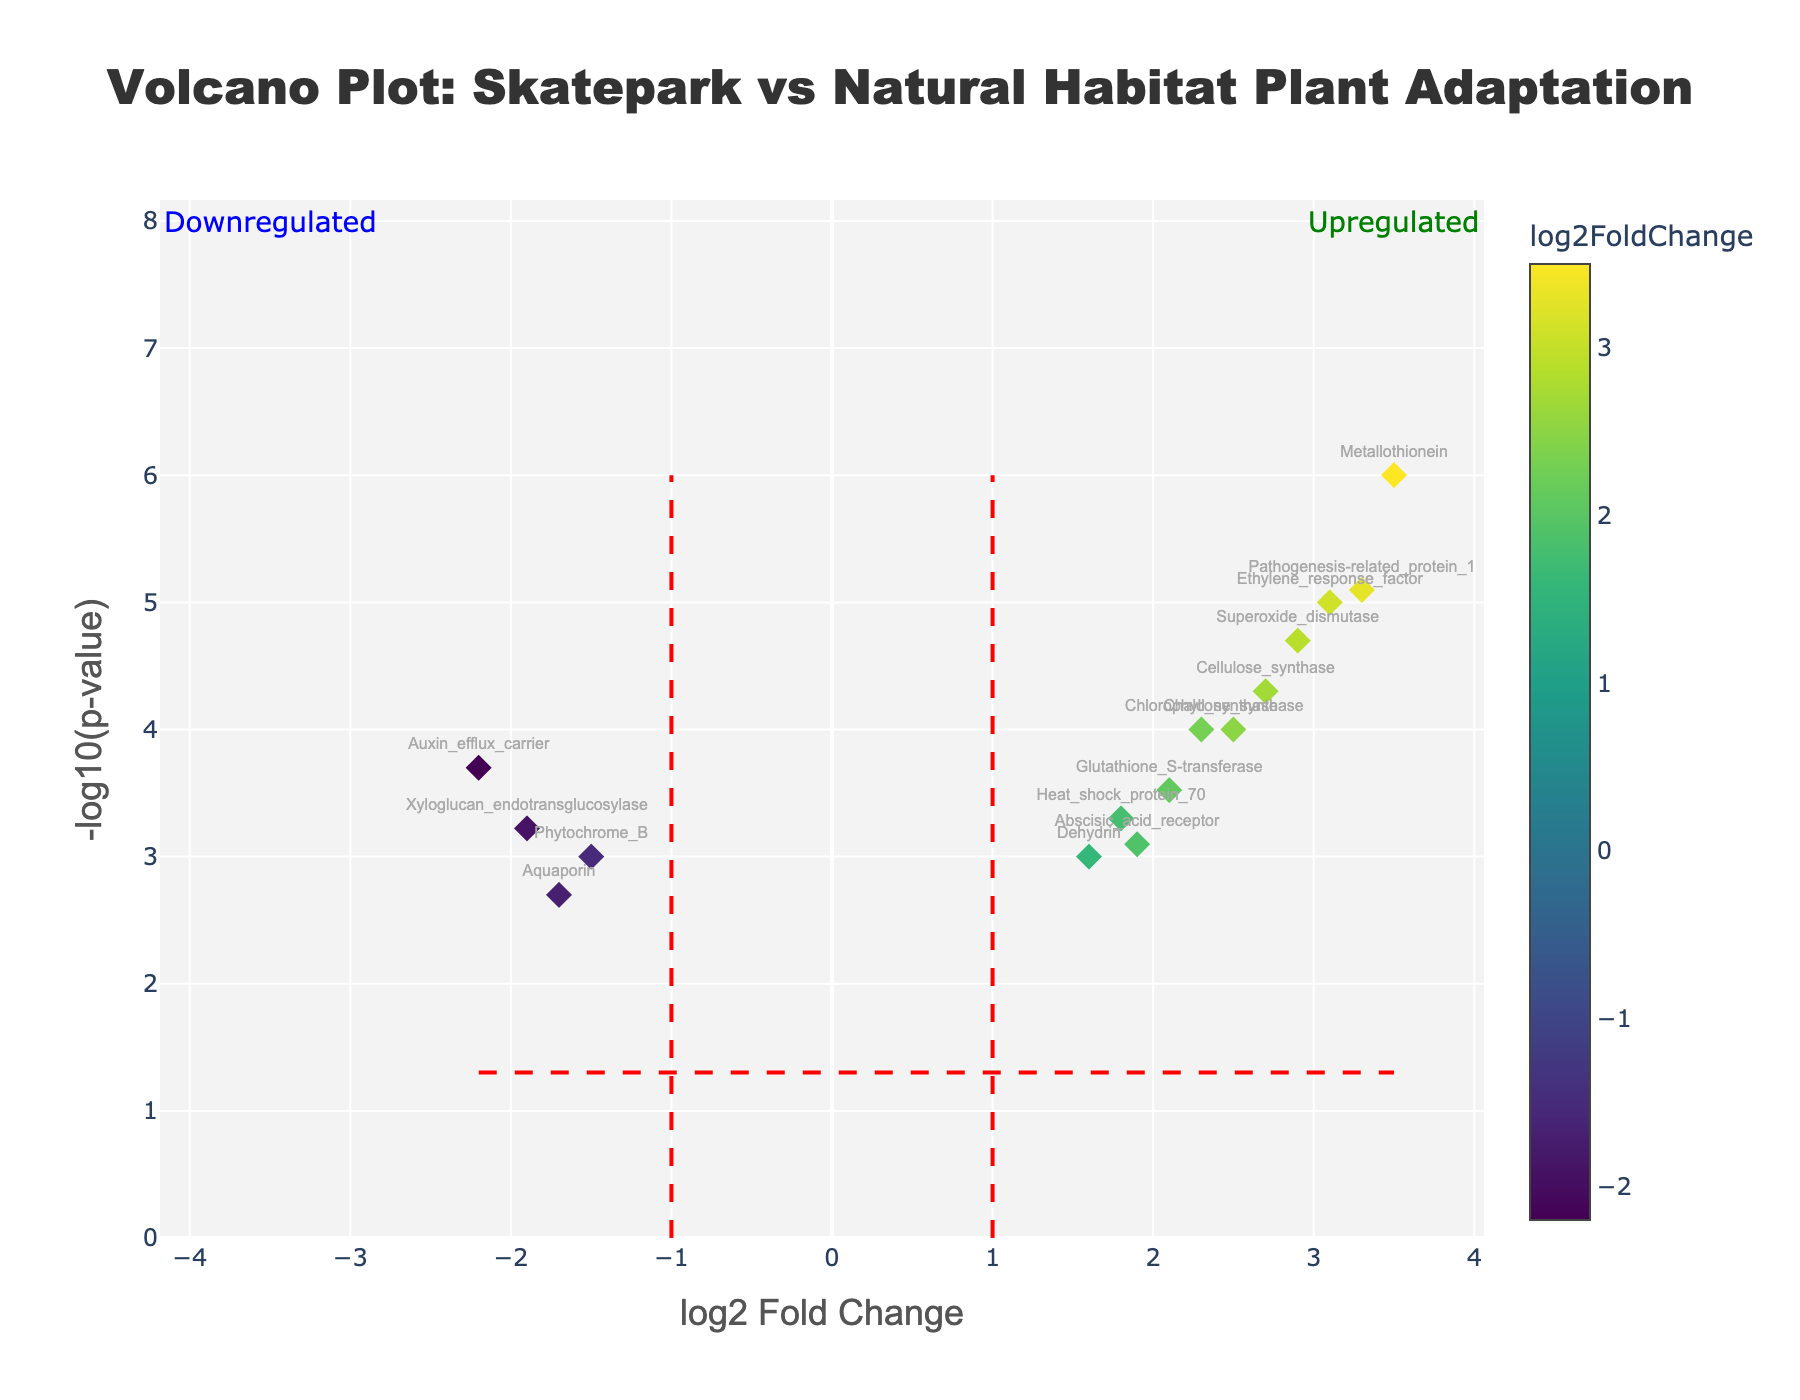What is the title of the figure? The title is usually located at the top of the figure. In this case, it is centered at the top and reads "Volcano Plot: Skatepark vs Natural Habitat Plant Adaptation".
Answer: "Volcano Plot: Skatepark vs Natural Habitat Plant Adaptation" What do the x-axis and y-axis represent? The x-axis title is “log2 Fold Change” and it indicates the fold change in gene expression levels, while the y-axis title is “-log10(p-value)” and it indicates the significance of the gene expression changes.
Answer: log2 Fold Change (x-axis) and -log10(p-value) (y-axis) Which gene has the highest -log10(p-value)? To find the gene with the highest -log10(p-value), look for the point that is highest on the y-axis. The gene "Metallothionein" appears at the highest point.
Answer: Metallothionein Which gene is most significantly downregulated in plants growing in skate parks? Downregulated genes have negative log2FoldChange values. Among them, identify the one with the highest -log10(p-value). "Auxin_efflux_carrier" has the most significant negative log2FoldChange and high -log10(p-value).
Answer: Auxin_efflux_carrier How many genes are upregulated with a log2FoldChange greater than 2? To determine this, count how many points are to the right of the vertical line at log2FoldChange = 2. The genes are "Chlorophyll_synthase", "Ethylene_response_factor", "Cellulose_synthase", "Metallothionein", "Pathogenesis-related_protein_1", and "Chalcone_synthase".
Answer: 6 What logarithmic fold change threshold is indicated by the vertical lines on the plot? The vertical lines are at log2FoldChange = -1 and log2FoldChange = 1, indicating the thresholds used to determine significant fold changes.
Answer: -1 and 1 Which gene has the lowest log2FoldChange value but is still statistically significant? Statistically significant genes have higher -log10(p-value) values, typically above the horizontal red line. Look for the gene with the most negative log2FoldChange within this group. The gene "Auxin_efflux_carrier" has the lowest log2FoldChange.
Answer: Auxin_efflux_carrier Which gene is closest to the threshold for statistical significance with a p-value near 0.05? Find the gene near the horizontal line indicating p = 0.05, corresponding to -log10(0.05). "Dehydrin" has a -log10(p-value) closest to the threshold.
Answer: Dehydrin Is Phytochrome_B upregulated or downregulated, and is its change statistically significant? Look for the position of "Phytochrome_B" on the plot. It has a negative log2FoldChange value, indicating downregulation, and it is above the horizontal line, indicating statistical significance.
Answer: Downregulated and statistically significant How does the expression of Superoxide_dismutase compare to that of Heat_shock_protein_70? Compare their log2FoldChange values and their positions on the y-axis for significance. "Superoxide_dismutase" has a higher log2FoldChange and -log10(p-value), meaning it is more upregulated and more statistically significant than "Heat_shock_protein_70".
Answer: Superoxide_dismutase is more upregulated and statistically significant than Heat_shock_protein_70 